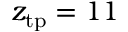Convert formula to latex. <formula><loc_0><loc_0><loc_500><loc_500>z _ { t p } = 1 1</formula> 